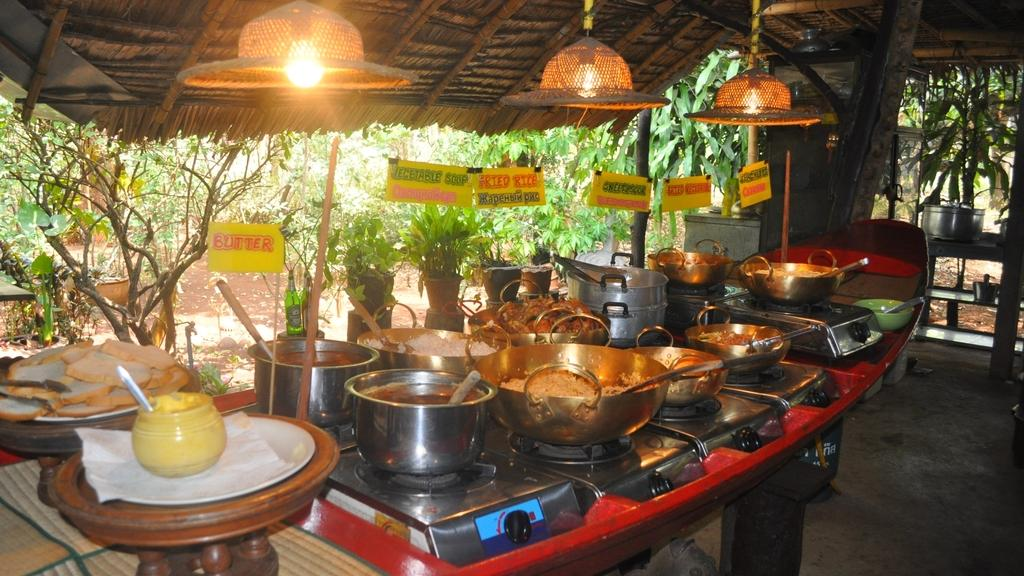What objects can be seen in the front of the image? In the front of the image, there are lights, boards, tables, stoves, food containers, a jar, food, and bottles. What type of food is visible in the image? There is food in the front of the image. What can be seen in the background of the image? In the background of the image, there are trees and plants. What type of paste is being used for educational purposes in the image? There is no paste or educational activity present in the image. Can you see any ears in the image? There are no ears visible in the image. 